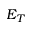Convert formula to latex. <formula><loc_0><loc_0><loc_500><loc_500>E _ { T }</formula> 